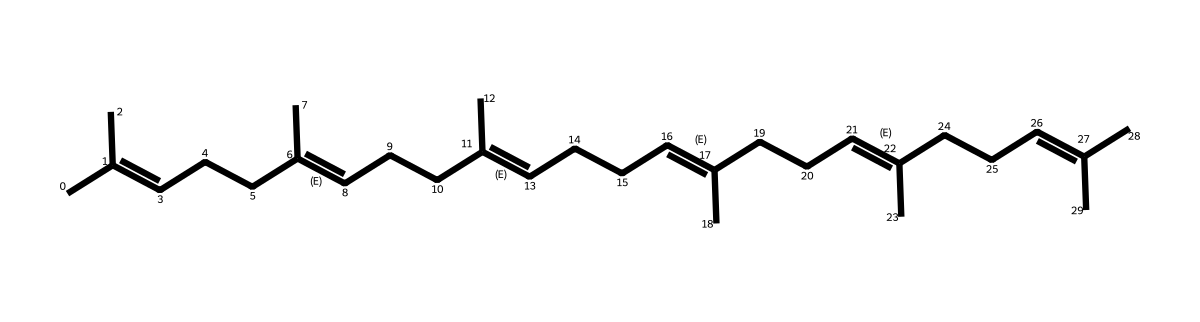What is the molecular formula of squalene? To determine the molecular formula, count the number of carbon (C) and hydrogen (H) atoms in the SMILES representation. The structure shows a total of 30 carbon atoms and 50 hydrogen atoms, resulting in the molecular formula C30H50.
Answer: C30H50 How many double bonds are present in squalene? By analyzing the SMILES representation, we identify the locations of double bonds (as indicated by the slashes and equal signs). The structure shows a total of 6 double bonds.
Answer: 6 What type of compound is squalene classified as? Squalene is classified as a terpenoid due to its structure, which consists of isoprene units and a long hydrocarbon chain. The arrangement and composition confirm its classification within this chemical type.
Answer: terpenoid What role does squalene play in the body? Squalene acts as a natural lubricant and is involved in the synthesis of steroid hormones and cholesterol, helping maintain cellular integrity and fluidity.
Answer: lubricant What is the significance of the branched structure in squalene? The branched structure contributes to its fluidity and efficacy as a lubricant, allowing it to reduce friction between surfaces and improve mobility. This characteristic is essential in natural lubricants.
Answer: fluidity 